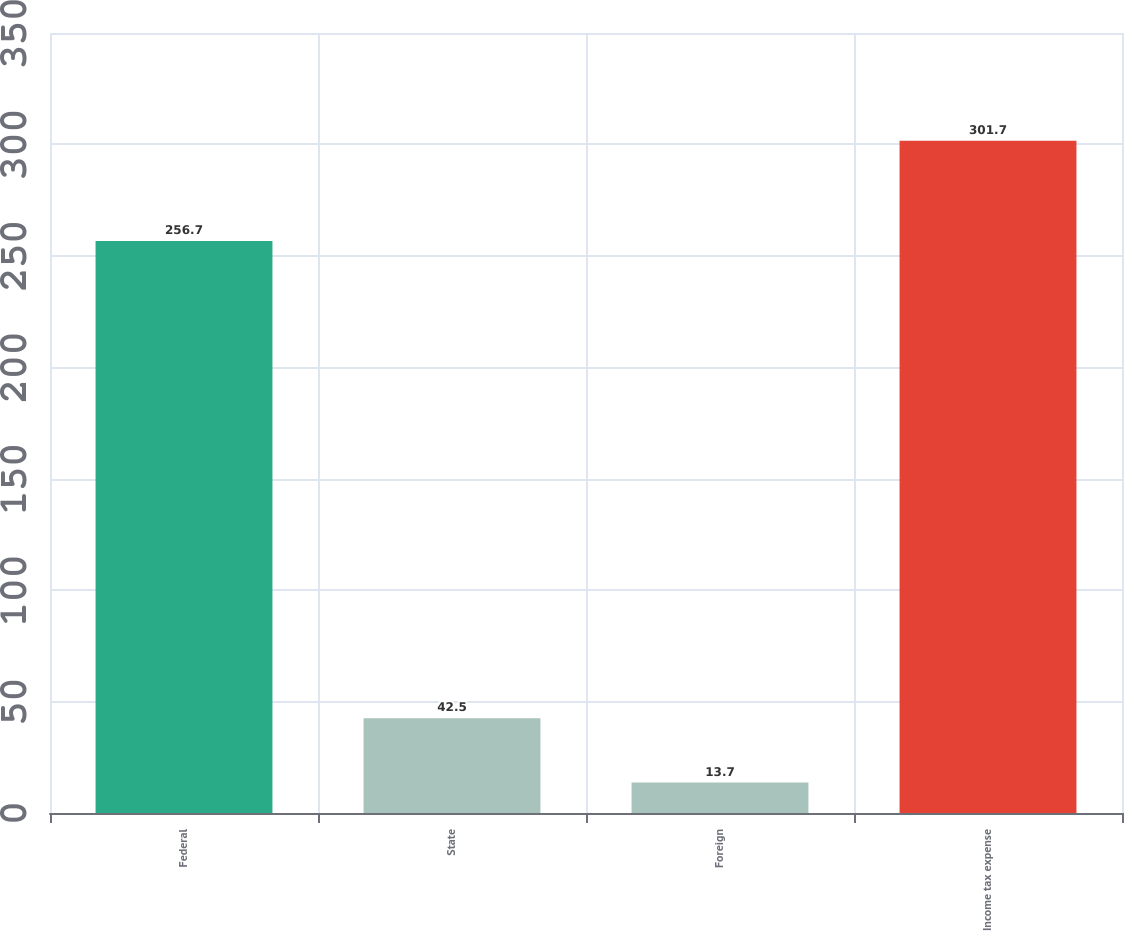<chart> <loc_0><loc_0><loc_500><loc_500><bar_chart><fcel>Federal<fcel>State<fcel>Foreign<fcel>Income tax expense<nl><fcel>256.7<fcel>42.5<fcel>13.7<fcel>301.7<nl></chart> 